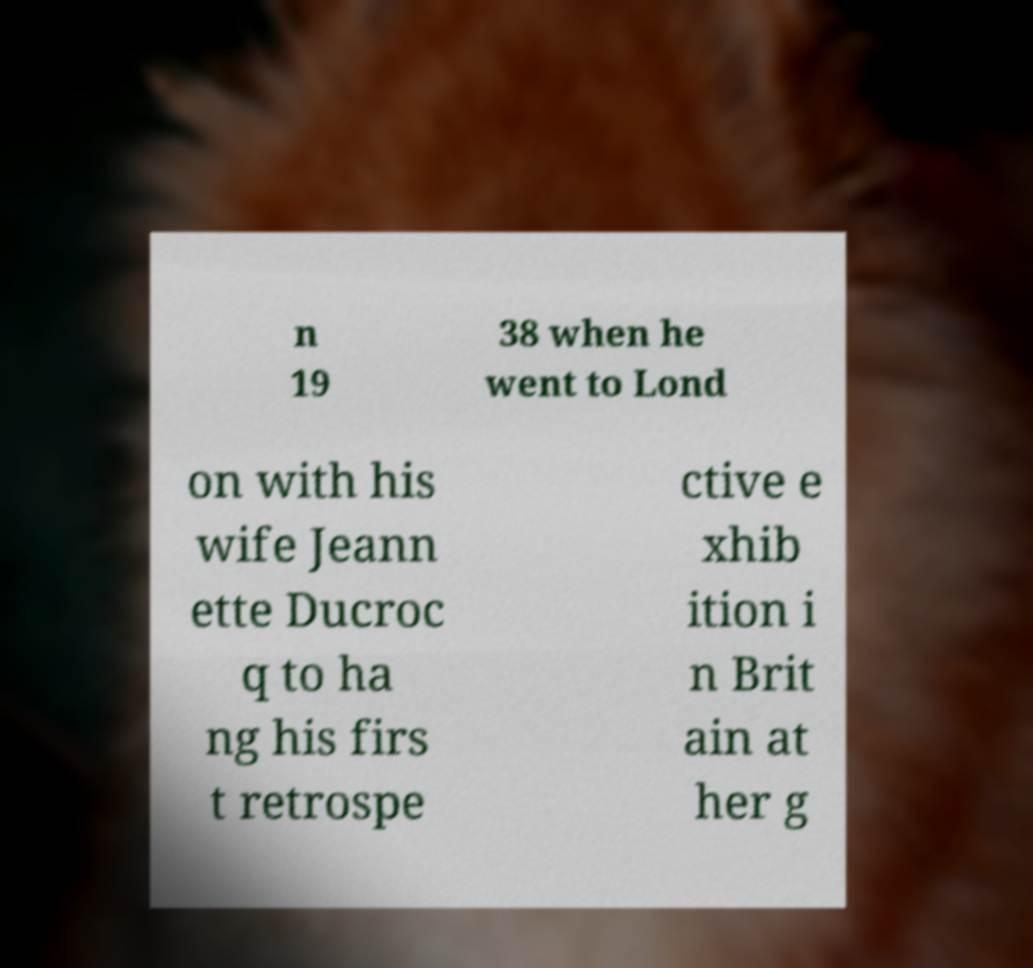Can you accurately transcribe the text from the provided image for me? n 19 38 when he went to Lond on with his wife Jeann ette Ducroc q to ha ng his firs t retrospe ctive e xhib ition i n Brit ain at her g 